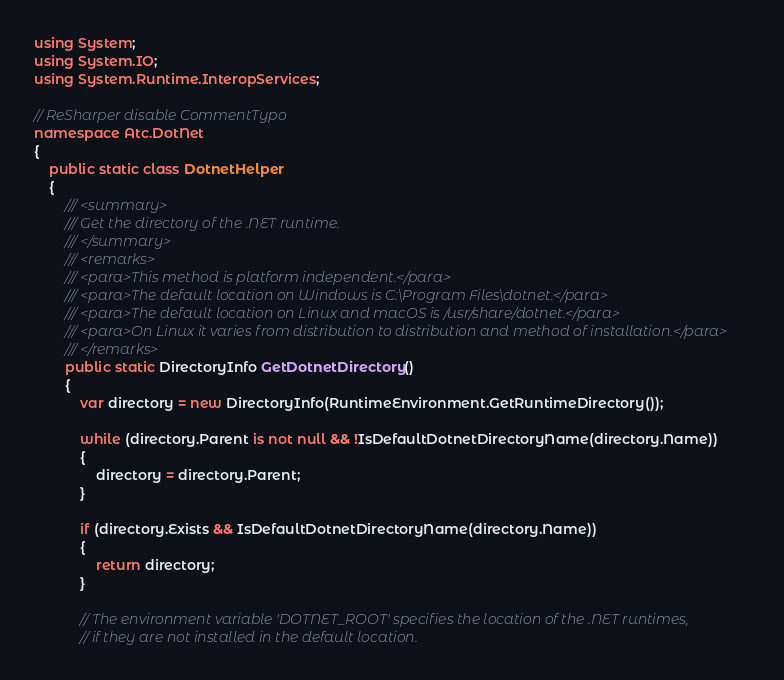<code> <loc_0><loc_0><loc_500><loc_500><_C#_>using System;
using System.IO;
using System.Runtime.InteropServices;

// ReSharper disable CommentTypo
namespace Atc.DotNet
{
    public static class DotnetHelper
    {
        /// <summary>
        /// Get the directory of the .NET runtime.
        /// </summary>
        /// <remarks>
        /// <para>This method is platform independent.</para>
        /// <para>The default location on Windows is C:\Program Files\dotnet.</para>
        /// <para>The default location on Linux and macOS is /usr/share/dotnet.</para>
        /// <para>On Linux it varies from distribution to distribution and method of installation.</para>
        /// </remarks>
        public static DirectoryInfo GetDotnetDirectory()
        {
            var directory = new DirectoryInfo(RuntimeEnvironment.GetRuntimeDirectory());

            while (directory.Parent is not null && !IsDefaultDotnetDirectoryName(directory.Name))
            {
                directory = directory.Parent;
            }

            if (directory.Exists && IsDefaultDotnetDirectoryName(directory.Name))
            {
                return directory;
            }

            // The environment variable 'DOTNET_ROOT' specifies the location of the .NET runtimes,
            // if they are not installed in the default location.</code> 